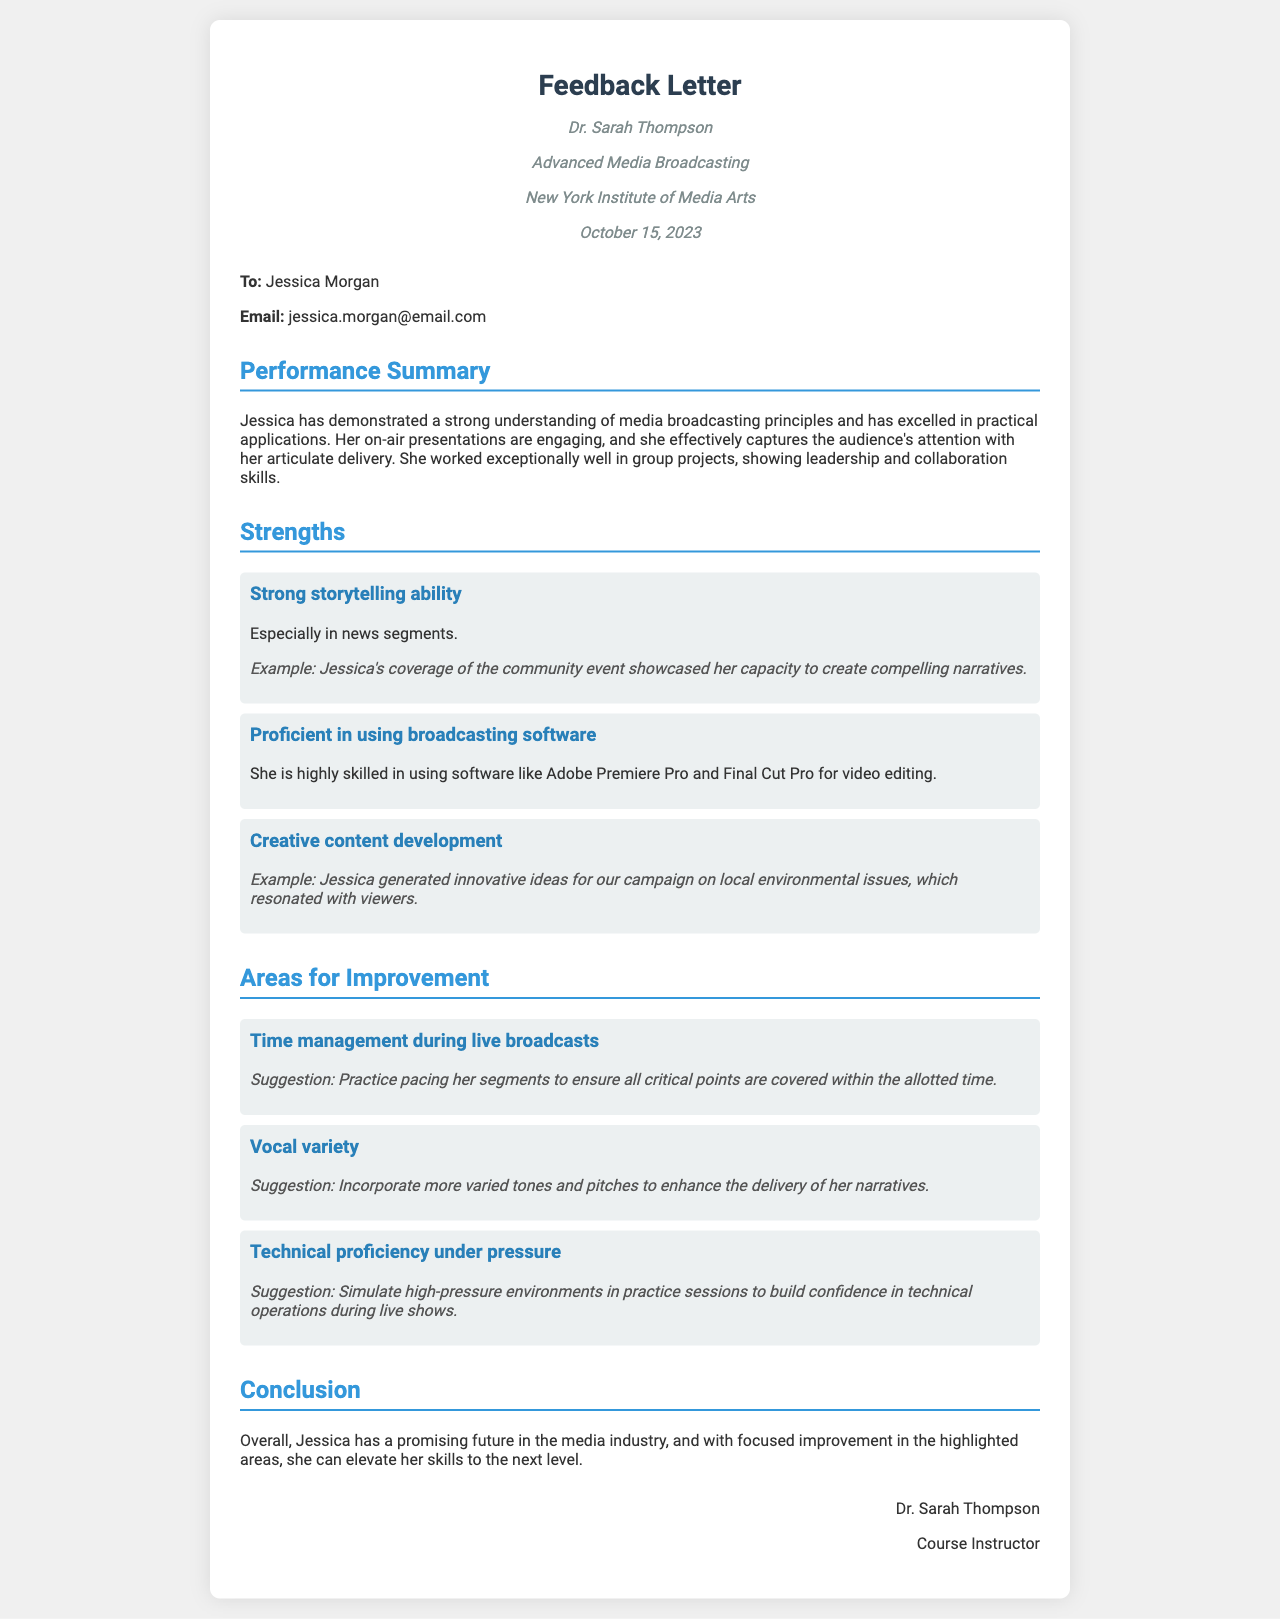What is the instructor's name? The instructor's name is mentioned at the top of the letter in the instructor info section.
Answer: Dr. Sarah Thompson What course does Jessica Morgan attend? The course is specified in the header of the letter.
Answer: Advanced Media Broadcasting What date was the feedback letter written? The date is provided in the instructor info section of the letter.
Answer: October 15, 2023 What is one of Jessica's strengths in storytelling? The strengths section identifies her storytelling ability, particularly in specific contexts.
Answer: Especially in news segments What software is Jessica proficient in? The document lists broadcasting software in the strengths section.
Answer: Adobe Premiere Pro and Final Cut Pro What is an area for improvement mentioned in the letter? Areas for improvement are listed and summarized in a specific section.
Answer: Time management during live broadcasts What suggestion is given for improving vocal variety? The suggestion for vocal variety is mentioned along with the specific area for improvement.
Answer: Incorporate more varied tones and pitches Who is the intended recipient of the letter? The recipient's name is specified in the student info section of the document.
Answer: Jessica Morgan What type of document is this? This question pertains to understanding the nature of the document itself based on its content.
Answer: Feedback Letter 